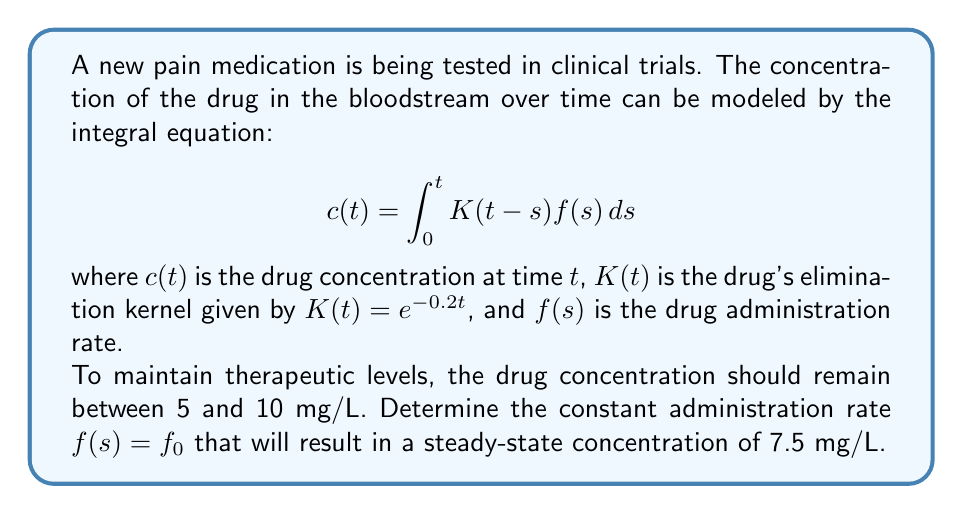Solve this math problem. Let's approach this step-by-step:

1) In steady-state, the concentration $c(t)$ becomes constant. Let's call this constant $c_{\infty}$. We're told this should be 7.5 mg/L.

2) For a constant administration rate $f_0$, the steady-state equation becomes:

   $$c_{\infty} = f_0 \int_0^{\infty} K(t)dt$$

3) We're given that $K(t) = e^{-0.2t}$. Let's solve the integral:

   $$\int_0^{\infty} K(t)dt = \int_0^{\infty} e^{-0.2t}dt = [-5e^{-0.2t}]_0^{\infty} = 5$$

4) Now our equation is:

   $$c_{\infty} = 5f_0$$

5) We want $c_{\infty} = 7.5$ mg/L, so:

   $$7.5 = 5f_0$$

6) Solving for $f_0$:

   $$f_0 = \frac{7.5}{5} = 1.5$$

Therefore, the constant administration rate should be 1.5 mg/L/hour to maintain a steady-state concentration of 7.5 mg/L.
Answer: $f_0 = 1.5$ mg/L/hour 